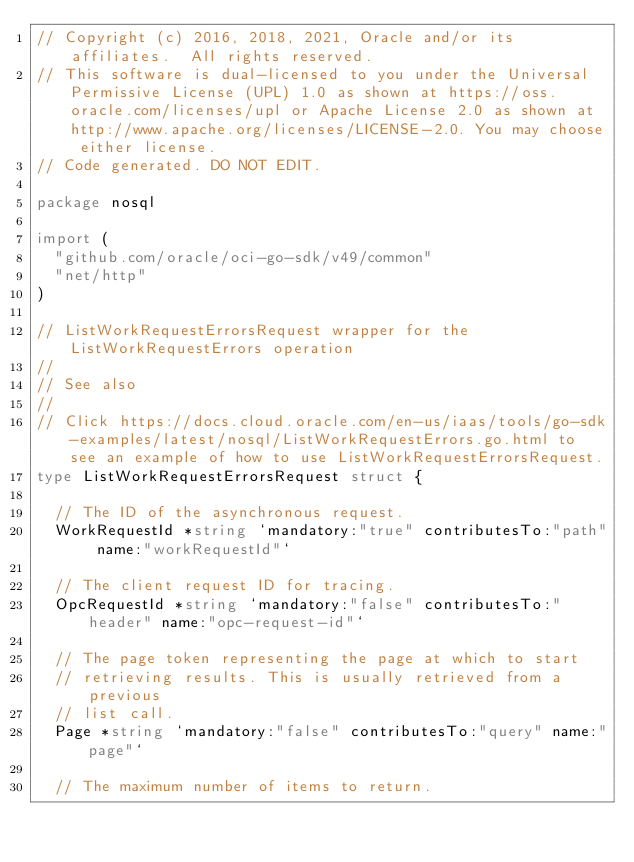<code> <loc_0><loc_0><loc_500><loc_500><_Go_>// Copyright (c) 2016, 2018, 2021, Oracle and/or its affiliates.  All rights reserved.
// This software is dual-licensed to you under the Universal Permissive License (UPL) 1.0 as shown at https://oss.oracle.com/licenses/upl or Apache License 2.0 as shown at http://www.apache.org/licenses/LICENSE-2.0. You may choose either license.
// Code generated. DO NOT EDIT.

package nosql

import (
	"github.com/oracle/oci-go-sdk/v49/common"
	"net/http"
)

// ListWorkRequestErrorsRequest wrapper for the ListWorkRequestErrors operation
//
// See also
//
// Click https://docs.cloud.oracle.com/en-us/iaas/tools/go-sdk-examples/latest/nosql/ListWorkRequestErrors.go.html to see an example of how to use ListWorkRequestErrorsRequest.
type ListWorkRequestErrorsRequest struct {

	// The ID of the asynchronous request.
	WorkRequestId *string `mandatory:"true" contributesTo:"path" name:"workRequestId"`

	// The client request ID for tracing.
	OpcRequestId *string `mandatory:"false" contributesTo:"header" name:"opc-request-id"`

	// The page token representing the page at which to start
	// retrieving results. This is usually retrieved from a previous
	// list call.
	Page *string `mandatory:"false" contributesTo:"query" name:"page"`

	// The maximum number of items to return.</code> 